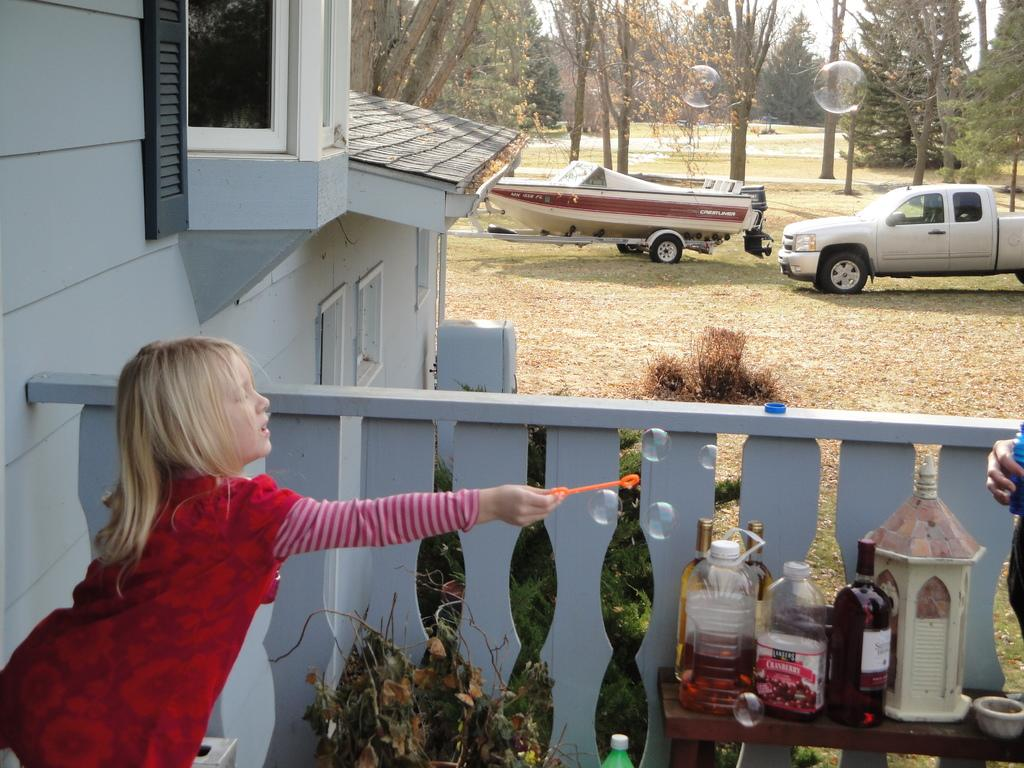Who is the main subject in the image? There is a girl in the image. What is located near the girl? There is a table with objects on it. What can be seen on the ground in the image? There are vehicles on the ground. What type of natural elements are visible in the image? There are trees visible in the image. What type of alarm can be heard going off in the image? There is no alarm present in the image, so it cannot be heard. 